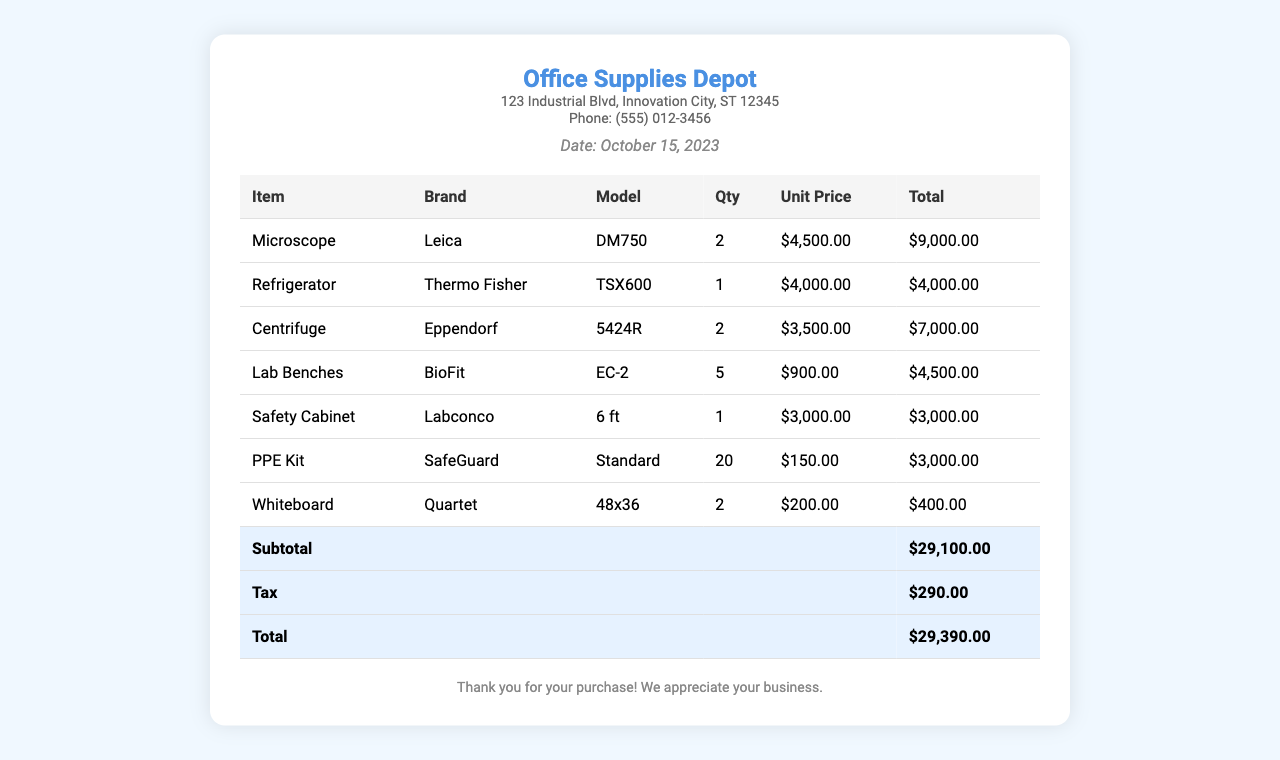What is the date of the receipt? The date of the receipt is specifically mentioned in the document.
Answer: October 15, 2023 How many microscopes were purchased? The quantity of microscopes bought is listed in the table under the 'Qty' column for that item.
Answer: 2 What is the total amount charged for the PPE kits? The total for PPE kits can be found in the 'Total' column in the corresponding row for the item.
Answer: $3,000.00 Which brand is the refrigerator from? The brand of the refrigerator is specified in the document under the 'Brand' column.
Answer: Thermo Fisher What is the subtotal of the purchases? The subtotal is calculated and presented as a line item in the totals section of the document.
Answer: $29,100.00 How many lab benches were ordered? The quantity of lab benches ordered is detailed in the 'Qty' column for that item.
Answer: 5 What is the total tax amount charged? The total tax is specifically mentioned in the totals section of the document.
Answer: $290.00 What type of safety cabinet was purchased? The model of the safety cabinet is indicated in the 'Model' column for that item.
Answer: 6 ft What is the brand of the centrifuge? The brand of the centrifuge is clearly mentioned in the document under the 'Brand' column for centrifuge.
Answer: Eppendorf 